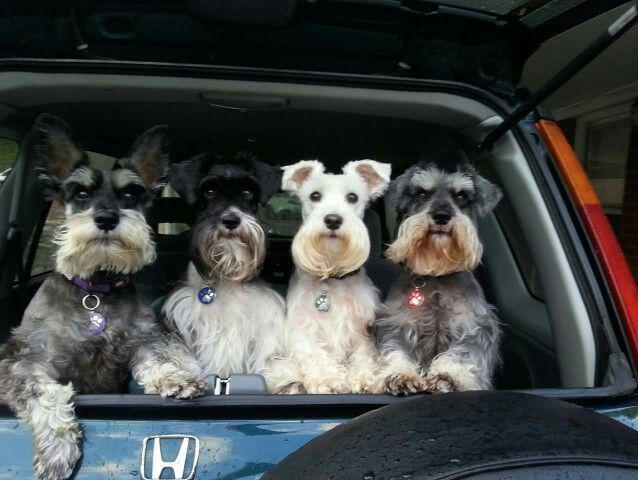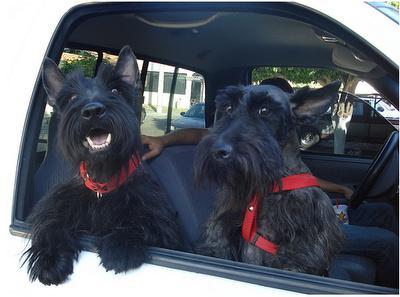The first image is the image on the left, the second image is the image on the right. Examine the images to the left and right. Is the description "there is no more then four dogs" accurate? Answer yes or no. No. 